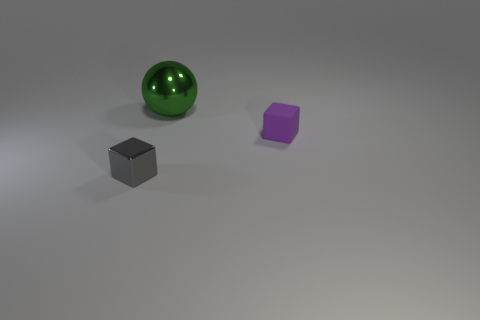How big is the rubber object?
Ensure brevity in your answer.  Small. There is another object that is the same shape as the gray object; what size is it?
Ensure brevity in your answer.  Small. There is a big green shiny thing; what number of small metallic things are behind it?
Ensure brevity in your answer.  0. The metal object that is right of the shiny object to the left of the big thing is what color?
Your answer should be very brief. Green. Is there anything else that is the same shape as the gray metal object?
Make the answer very short. Yes. Are there the same number of metallic blocks that are left of the green shiny thing and big things that are in front of the purple block?
Provide a short and direct response. No. How many cylinders are either large objects or metal things?
Keep it short and to the point. 0. How many other things are there of the same material as the sphere?
Offer a very short reply. 1. There is a tiny object behind the tiny gray metal cube; what shape is it?
Your answer should be very brief. Cube. What material is the thing that is in front of the tiny cube behind the tiny gray cube?
Offer a very short reply. Metal. 